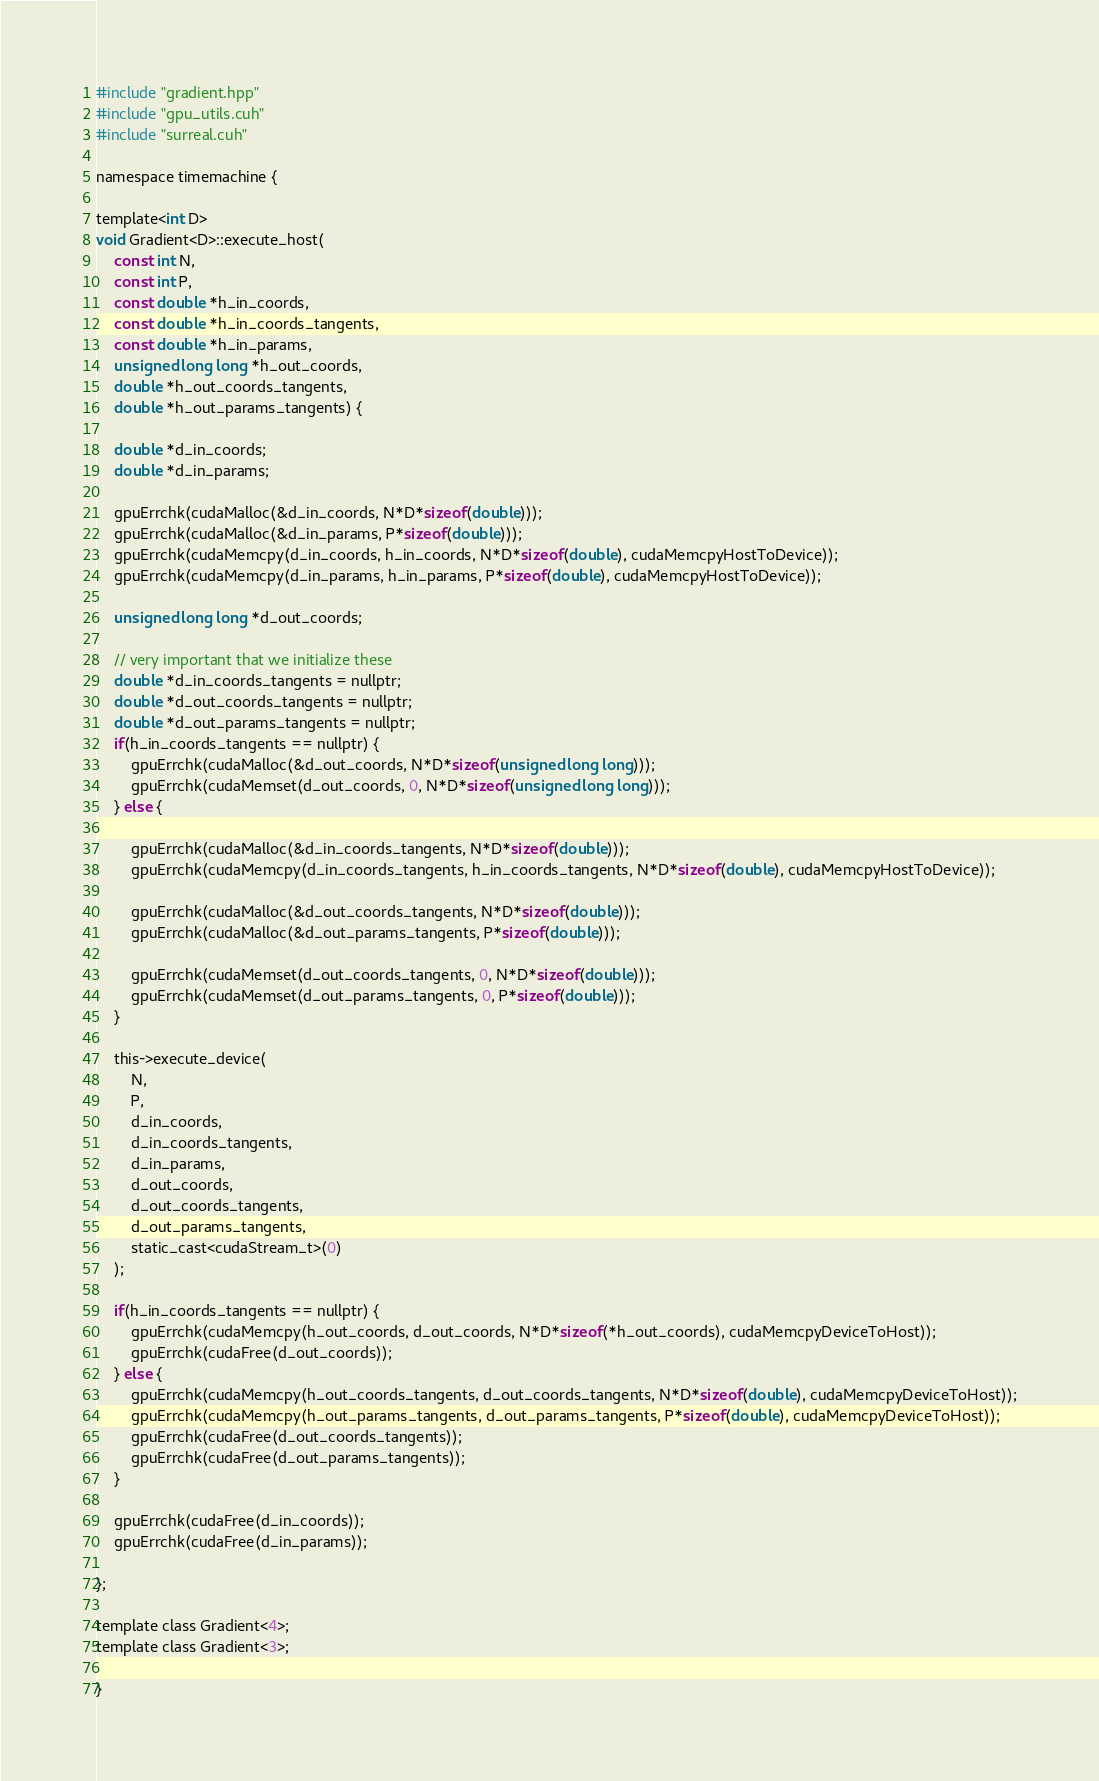<code> <loc_0><loc_0><loc_500><loc_500><_Cuda_>
#include "gradient.hpp"
#include "gpu_utils.cuh"
#include "surreal.cuh"

namespace timemachine {

template<int D>
void Gradient<D>::execute_host(
    const int N,
    const int P,
    const double *h_in_coords,
    const double *h_in_coords_tangents,
    const double *h_in_params,
    unsigned long long *h_out_coords,
    double *h_out_coords_tangents,
    double *h_out_params_tangents) {

    double *d_in_coords;
    double *d_in_params;

    gpuErrchk(cudaMalloc(&d_in_coords, N*D*sizeof(double)));
    gpuErrchk(cudaMalloc(&d_in_params, P*sizeof(double)));
    gpuErrchk(cudaMemcpy(d_in_coords, h_in_coords, N*D*sizeof(double), cudaMemcpyHostToDevice));
    gpuErrchk(cudaMemcpy(d_in_params, h_in_params, P*sizeof(double), cudaMemcpyHostToDevice));

    unsigned long long *d_out_coords;

    // very important that we initialize these
    double *d_in_coords_tangents = nullptr;
    double *d_out_coords_tangents = nullptr;
    double *d_out_params_tangents = nullptr;
    if(h_in_coords_tangents == nullptr) {
        gpuErrchk(cudaMalloc(&d_out_coords, N*D*sizeof(unsigned long long)));
        gpuErrchk(cudaMemset(d_out_coords, 0, N*D*sizeof(unsigned long long)));
    } else {

        gpuErrchk(cudaMalloc(&d_in_coords_tangents, N*D*sizeof(double)));
        gpuErrchk(cudaMemcpy(d_in_coords_tangents, h_in_coords_tangents, N*D*sizeof(double), cudaMemcpyHostToDevice));

        gpuErrchk(cudaMalloc(&d_out_coords_tangents, N*D*sizeof(double)));
        gpuErrchk(cudaMalloc(&d_out_params_tangents, P*sizeof(double)));

        gpuErrchk(cudaMemset(d_out_coords_tangents, 0, N*D*sizeof(double)));
        gpuErrchk(cudaMemset(d_out_params_tangents, 0, P*sizeof(double)));
    }

    this->execute_device(
        N,
        P,
        d_in_coords, 
        d_in_coords_tangents,
        d_in_params,
        d_out_coords,
        d_out_coords_tangents,
        d_out_params_tangents,
        static_cast<cudaStream_t>(0)
    );

    if(h_in_coords_tangents == nullptr) {
        gpuErrchk(cudaMemcpy(h_out_coords, d_out_coords, N*D*sizeof(*h_out_coords), cudaMemcpyDeviceToHost));
        gpuErrchk(cudaFree(d_out_coords));
    } else {
        gpuErrchk(cudaMemcpy(h_out_coords_tangents, d_out_coords_tangents, N*D*sizeof(double), cudaMemcpyDeviceToHost));
        gpuErrchk(cudaMemcpy(h_out_params_tangents, d_out_params_tangents, P*sizeof(double), cudaMemcpyDeviceToHost));
        gpuErrchk(cudaFree(d_out_coords_tangents));
        gpuErrchk(cudaFree(d_out_params_tangents));
    }

    gpuErrchk(cudaFree(d_in_coords));
    gpuErrchk(cudaFree(d_in_params));

};

template class Gradient<4>; 
template class Gradient<3>;

}

</code> 